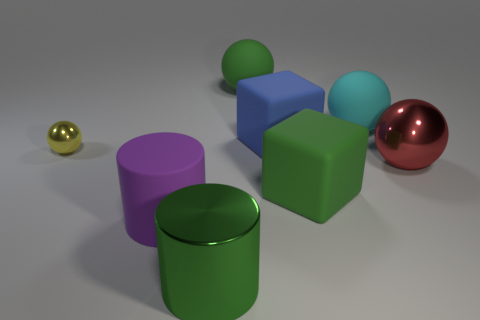How many things are objects that are to the right of the large cyan object or large green objects?
Your response must be concise. 4. Is the number of green rubber cubes left of the big purple cylinder the same as the number of small spheres?
Your answer should be very brief. No. The large thing that is in front of the cyan sphere and behind the big red metallic sphere is what color?
Make the answer very short. Blue. What number of balls are either large green metallic things or large blue things?
Offer a very short reply. 0. Are there fewer large green rubber things left of the big blue thing than big green things?
Offer a very short reply. Yes. What shape is the large blue object that is made of the same material as the purple cylinder?
Make the answer very short. Cube. What number of small spheres have the same color as the shiny cylinder?
Make the answer very short. 0. How many objects are either small rubber objects or big spheres?
Provide a succinct answer. 3. What material is the sphere that is on the left side of the large object that is behind the cyan matte sphere?
Offer a very short reply. Metal. Are there any large gray cubes that have the same material as the big blue cube?
Offer a terse response. No. 